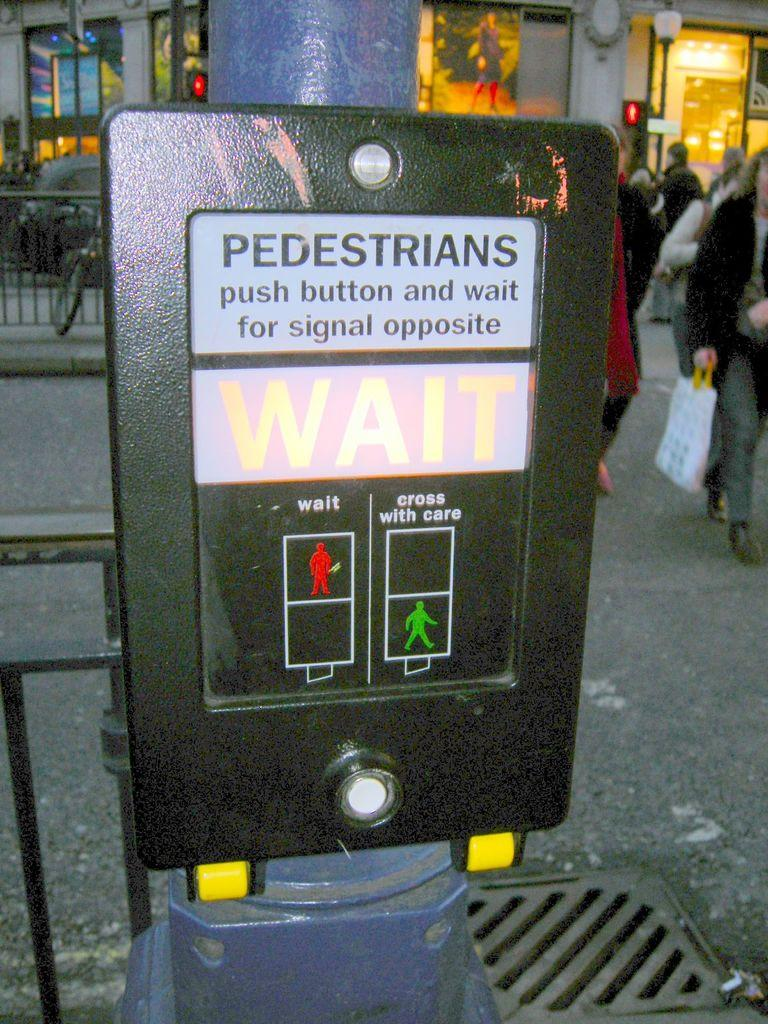What is the main object in the image? There is a sign board in the image. Are there any people present in the image? Yes, there are people in the image. What can be seen on the left side of the image? There is a bicycle and a car on the left side of the image. What is the purpose of the railing in the image? The railing is likely there for safety or to prevent people from falling. What is visible in the background of the image? There is a building in the background of the image. How many times does the building twist in the image? There is no building twisting in the image; it is a stationary structure in the background. Can you describe the kicking motion of the people in the image? There is no kicking motion depicted in the image; the people are not engaged in any such activity. 